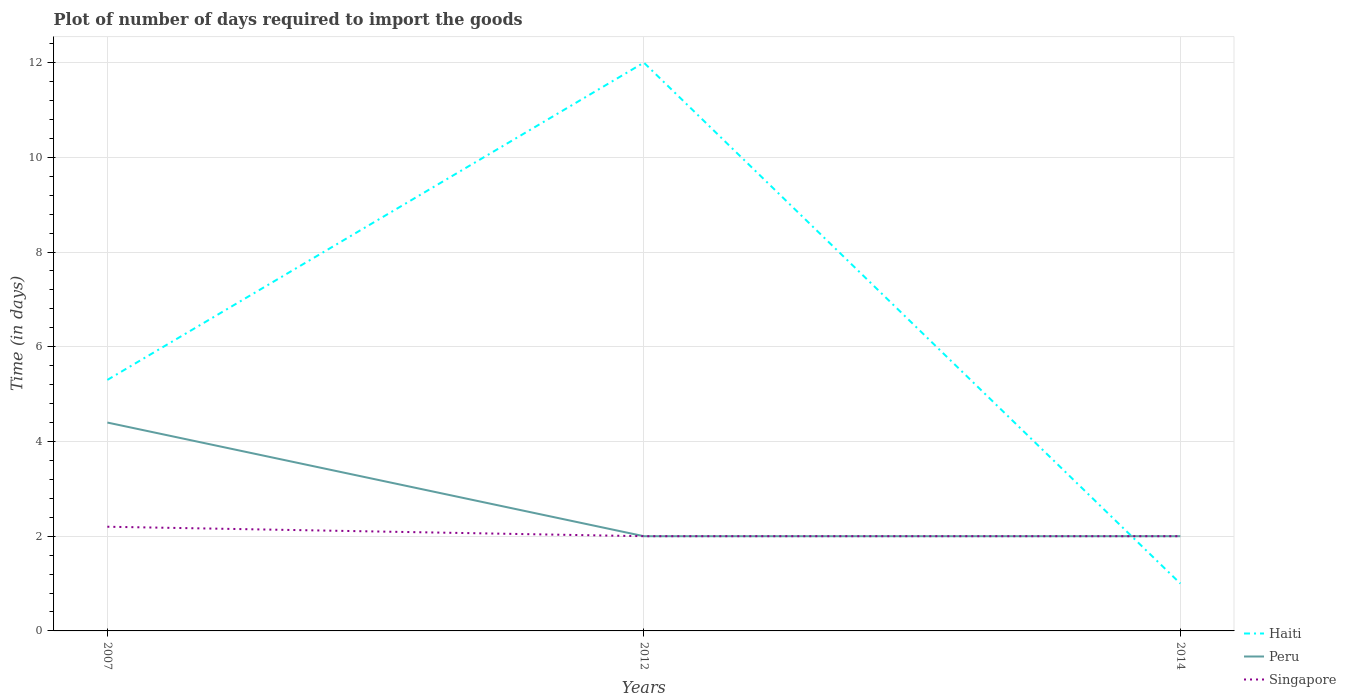Does the line corresponding to Haiti intersect with the line corresponding to Singapore?
Offer a very short reply. Yes. Across all years, what is the maximum time required to import goods in Peru?
Offer a very short reply. 2. In which year was the time required to import goods in Peru maximum?
Your answer should be compact. 2012. What is the total time required to import goods in Peru in the graph?
Your answer should be compact. 2.4. What is the difference between the highest and the second highest time required to import goods in Haiti?
Provide a short and direct response. 11. What is the difference between the highest and the lowest time required to import goods in Singapore?
Give a very brief answer. 1. Is the time required to import goods in Singapore strictly greater than the time required to import goods in Haiti over the years?
Your answer should be compact. No. How many years are there in the graph?
Make the answer very short. 3. What is the difference between two consecutive major ticks on the Y-axis?
Give a very brief answer. 2. Does the graph contain grids?
Your answer should be very brief. Yes. How many legend labels are there?
Keep it short and to the point. 3. How are the legend labels stacked?
Give a very brief answer. Vertical. What is the title of the graph?
Offer a terse response. Plot of number of days required to import the goods. Does "Sint Maarten (Dutch part)" appear as one of the legend labels in the graph?
Provide a succinct answer. No. What is the label or title of the X-axis?
Make the answer very short. Years. What is the label or title of the Y-axis?
Offer a terse response. Time (in days). What is the Time (in days) in Peru in 2007?
Make the answer very short. 4.4. What is the Time (in days) in Haiti in 2012?
Offer a very short reply. 12. What is the Time (in days) of Singapore in 2012?
Offer a very short reply. 2. What is the Time (in days) in Peru in 2014?
Provide a succinct answer. 2. Across all years, what is the maximum Time (in days) of Haiti?
Give a very brief answer. 12. Across all years, what is the maximum Time (in days) of Peru?
Give a very brief answer. 4.4. Across all years, what is the maximum Time (in days) in Singapore?
Offer a very short reply. 2.2. Across all years, what is the minimum Time (in days) in Haiti?
Ensure brevity in your answer.  1. Across all years, what is the minimum Time (in days) in Peru?
Keep it short and to the point. 2. Across all years, what is the minimum Time (in days) of Singapore?
Your answer should be very brief. 2. What is the total Time (in days) of Peru in the graph?
Provide a short and direct response. 8.4. What is the difference between the Time (in days) of Haiti in 2007 and that in 2012?
Your response must be concise. -6.7. What is the difference between the Time (in days) of Peru in 2007 and that in 2012?
Provide a succinct answer. 2.4. What is the difference between the Time (in days) in Singapore in 2007 and that in 2012?
Your response must be concise. 0.2. What is the difference between the Time (in days) in Haiti in 2007 and that in 2014?
Your answer should be very brief. 4.3. What is the difference between the Time (in days) in Peru in 2007 and that in 2014?
Your answer should be very brief. 2.4. What is the difference between the Time (in days) of Haiti in 2012 and that in 2014?
Provide a succinct answer. 11. What is the difference between the Time (in days) in Peru in 2012 and that in 2014?
Ensure brevity in your answer.  0. What is the difference between the Time (in days) of Singapore in 2012 and that in 2014?
Offer a terse response. 0. What is the difference between the Time (in days) in Haiti in 2007 and the Time (in days) in Singapore in 2012?
Offer a very short reply. 3.3. What is the difference between the Time (in days) in Peru in 2007 and the Time (in days) in Singapore in 2012?
Make the answer very short. 2.4. What is the difference between the Time (in days) of Haiti in 2007 and the Time (in days) of Peru in 2014?
Your answer should be very brief. 3.3. What is the difference between the Time (in days) in Haiti in 2007 and the Time (in days) in Singapore in 2014?
Offer a very short reply. 3.3. What is the difference between the Time (in days) in Haiti in 2012 and the Time (in days) in Singapore in 2014?
Your response must be concise. 10. What is the difference between the Time (in days) in Peru in 2012 and the Time (in days) in Singapore in 2014?
Your response must be concise. 0. What is the average Time (in days) of Peru per year?
Your answer should be very brief. 2.8. What is the average Time (in days) of Singapore per year?
Provide a short and direct response. 2.07. In the year 2007, what is the difference between the Time (in days) in Haiti and Time (in days) in Peru?
Your response must be concise. 0.9. In the year 2012, what is the difference between the Time (in days) in Haiti and Time (in days) in Singapore?
Provide a short and direct response. 10. In the year 2014, what is the difference between the Time (in days) of Peru and Time (in days) of Singapore?
Your response must be concise. 0. What is the ratio of the Time (in days) in Haiti in 2007 to that in 2012?
Make the answer very short. 0.44. What is the ratio of the Time (in days) in Haiti in 2007 to that in 2014?
Keep it short and to the point. 5.3. What is the ratio of the Time (in days) in Peru in 2012 to that in 2014?
Keep it short and to the point. 1. What is the difference between the highest and the second highest Time (in days) of Peru?
Offer a very short reply. 2.4. What is the difference between the highest and the lowest Time (in days) in Peru?
Provide a short and direct response. 2.4. 